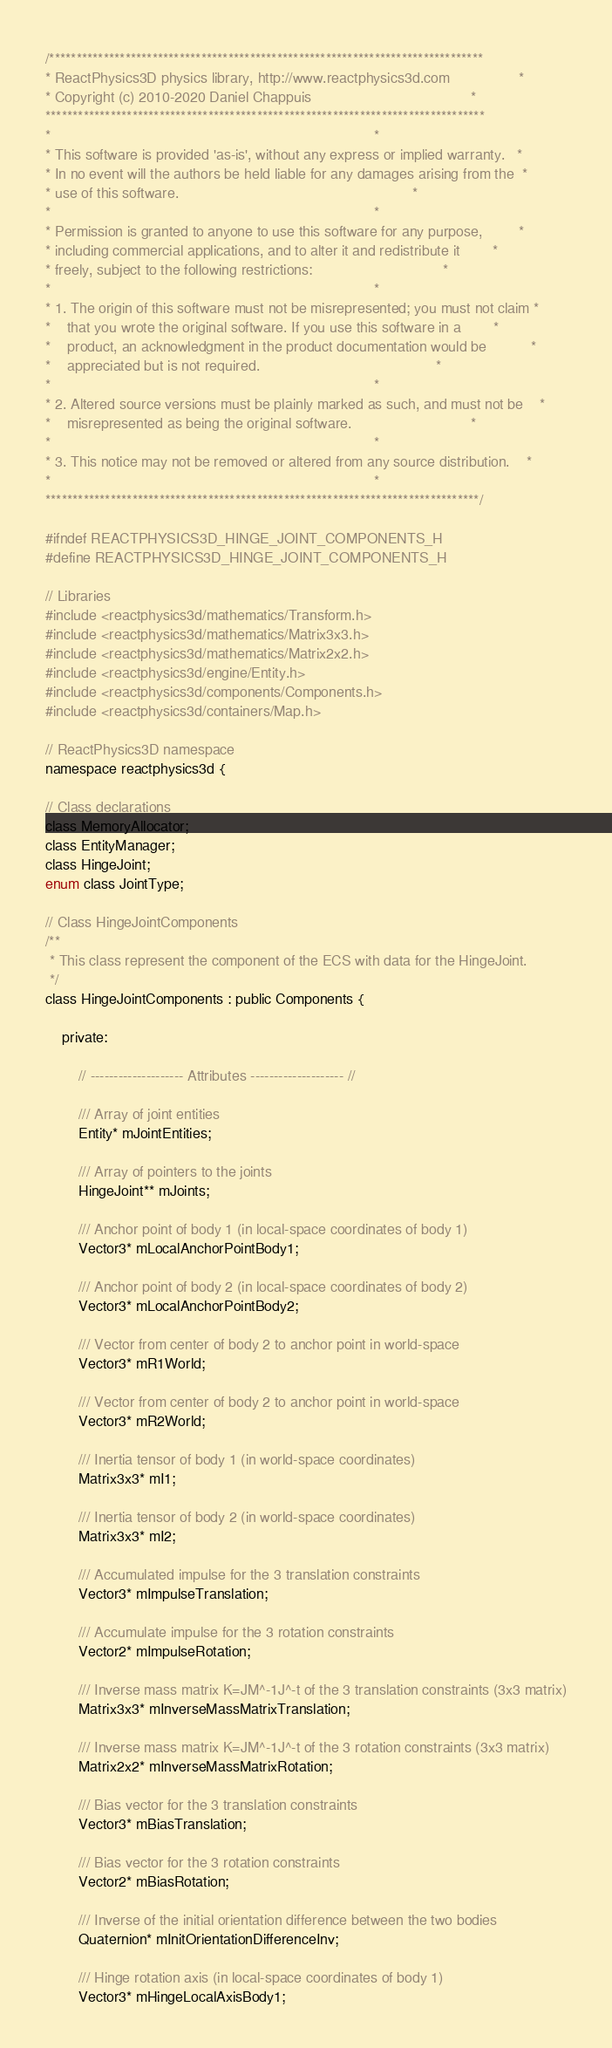<code> <loc_0><loc_0><loc_500><loc_500><_C_>/********************************************************************************
* ReactPhysics3D physics library, http://www.reactphysics3d.com                 *
* Copyright (c) 2010-2020 Daniel Chappuis                                       *
*********************************************************************************
*                                                                               *
* This software is provided 'as-is', without any express or implied warranty.   *
* In no event will the authors be held liable for any damages arising from the  *
* use of this software.                                                         *
*                                                                               *
* Permission is granted to anyone to use this software for any purpose,         *
* including commercial applications, and to alter it and redistribute it        *
* freely, subject to the following restrictions:                                *
*                                                                               *
* 1. The origin of this software must not be misrepresented; you must not claim *
*    that you wrote the original software. If you use this software in a        *
*    product, an acknowledgment in the product documentation would be           *
*    appreciated but is not required.                                           *
*                                                                               *
* 2. Altered source versions must be plainly marked as such, and must not be    *
*    misrepresented as being the original software.                             *
*                                                                               *
* 3. This notice may not be removed or altered from any source distribution.    *
*                                                                               *
********************************************************************************/

#ifndef REACTPHYSICS3D_HINGE_JOINT_COMPONENTS_H
#define REACTPHYSICS3D_HINGE_JOINT_COMPONENTS_H

// Libraries
#include <reactphysics3d/mathematics/Transform.h>
#include <reactphysics3d/mathematics/Matrix3x3.h>
#include <reactphysics3d/mathematics/Matrix2x2.h>
#include <reactphysics3d/engine/Entity.h>
#include <reactphysics3d/components/Components.h>
#include <reactphysics3d/containers/Map.h>

// ReactPhysics3D namespace
namespace reactphysics3d {

// Class declarations
class MemoryAllocator;
class EntityManager;
class HingeJoint;
enum class JointType;

// Class HingeJointComponents
/**
 * This class represent the component of the ECS with data for the HingeJoint.
 */
class HingeJointComponents : public Components {

    private:

        // -------------------- Attributes -------------------- //

        /// Array of joint entities
        Entity* mJointEntities;

        /// Array of pointers to the joints
        HingeJoint** mJoints;

        /// Anchor point of body 1 (in local-space coordinates of body 1)
        Vector3* mLocalAnchorPointBody1;

        /// Anchor point of body 2 (in local-space coordinates of body 2)
        Vector3* mLocalAnchorPointBody2;

        /// Vector from center of body 2 to anchor point in world-space
        Vector3* mR1World;

        /// Vector from center of body 2 to anchor point in world-space
        Vector3* mR2World;

        /// Inertia tensor of body 1 (in world-space coordinates)
        Matrix3x3* mI1;

        /// Inertia tensor of body 2 (in world-space coordinates)
        Matrix3x3* mI2;

        /// Accumulated impulse for the 3 translation constraints
        Vector3* mImpulseTranslation;

        /// Accumulate impulse for the 3 rotation constraints
        Vector2* mImpulseRotation;

        /// Inverse mass matrix K=JM^-1J^-t of the 3 translation constraints (3x3 matrix)
        Matrix3x3* mInverseMassMatrixTranslation;

        /// Inverse mass matrix K=JM^-1J^-t of the 3 rotation constraints (3x3 matrix)
        Matrix2x2* mInverseMassMatrixRotation;

        /// Bias vector for the 3 translation constraints
        Vector3* mBiasTranslation;

        /// Bias vector for the 3 rotation constraints
        Vector2* mBiasRotation;

        /// Inverse of the initial orientation difference between the two bodies
        Quaternion* mInitOrientationDifferenceInv;

        /// Hinge rotation axis (in local-space coordinates of body 1)
        Vector3* mHingeLocalAxisBody1;
</code> 